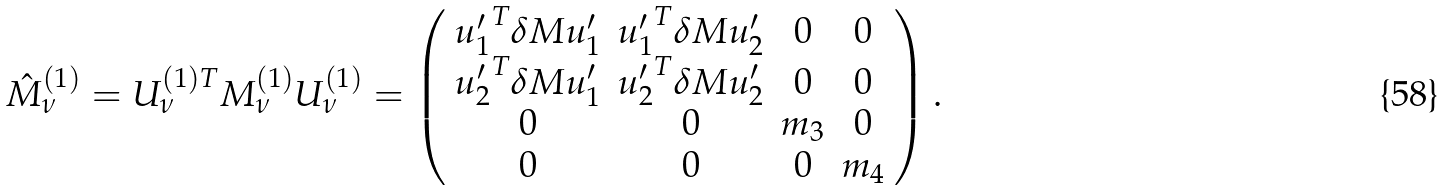<formula> <loc_0><loc_0><loc_500><loc_500>\hat { M } ^ { ( 1 ) } _ { \nu } = U _ { \nu } ^ { ( 1 ) T } M _ { \nu } ^ { ( 1 ) } U _ { \nu } ^ { ( 1 ) } = \left ( \begin{array} { c c c c } { u ^ { \prime } _ { 1 } } ^ { T } \delta M u ^ { \prime } _ { 1 } & { u ^ { \prime } _ { 1 } } ^ { T } \delta M u ^ { \prime } _ { 2 } & 0 & 0 \\ { u ^ { \prime } _ { 2 } } ^ { T } \delta M u ^ { \prime } _ { 1 } & { u ^ { \prime } _ { 2 } } ^ { T } \delta M u ^ { \prime } _ { 2 } & 0 & 0 \\ 0 & 0 & m _ { 3 } & 0 \\ 0 & 0 & 0 & m _ { 4 } \end{array} \right ) .</formula> 